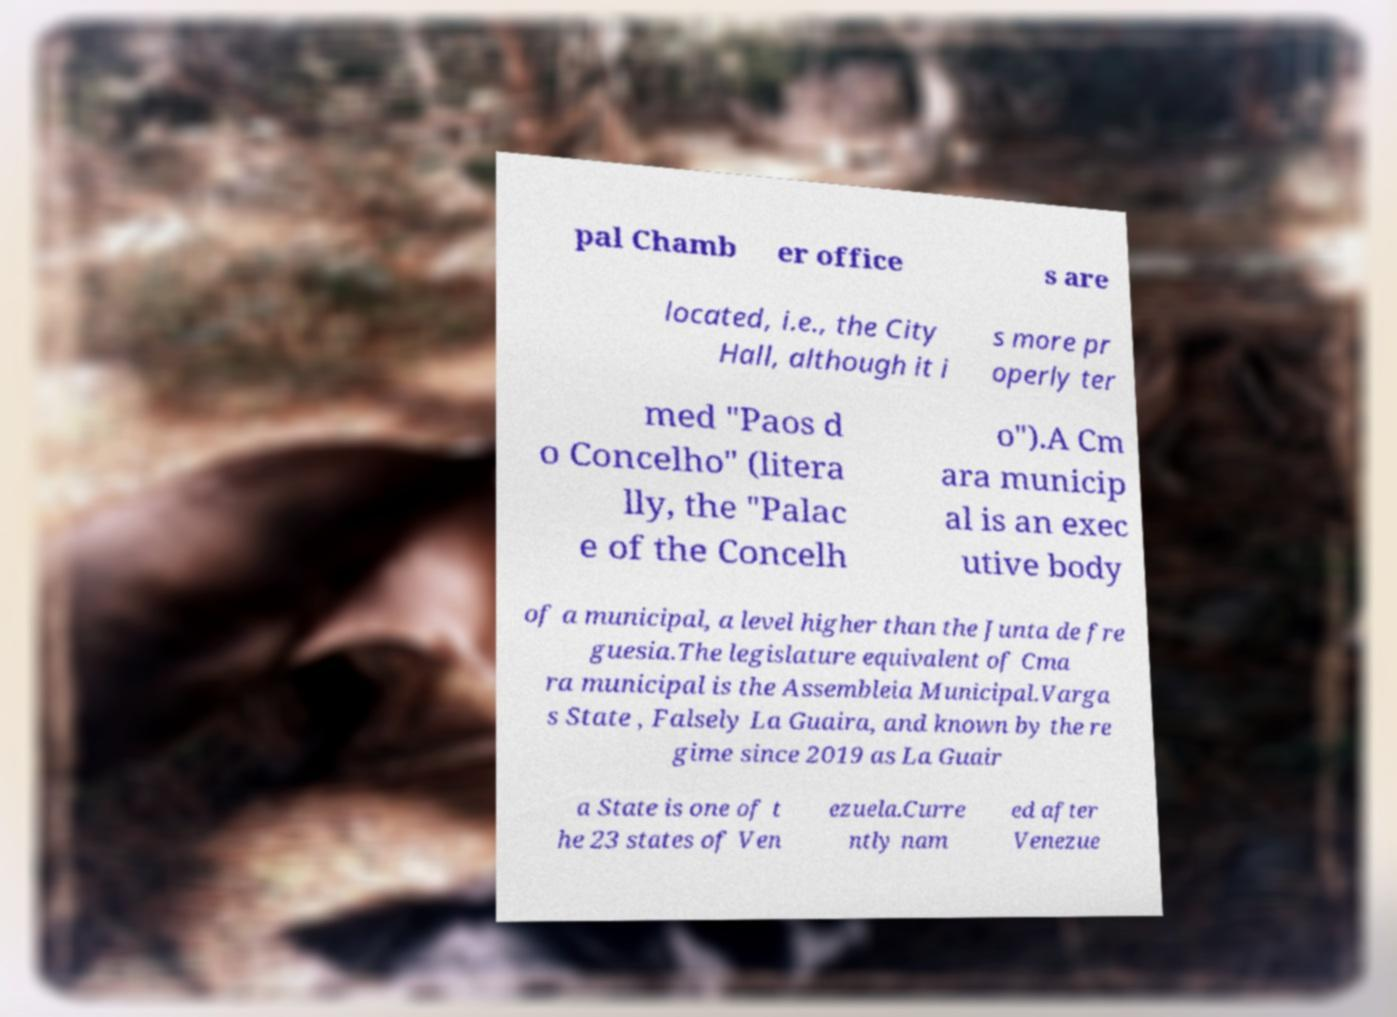Can you accurately transcribe the text from the provided image for me? pal Chamb er office s are located, i.e., the City Hall, although it i s more pr operly ter med "Paos d o Concelho" (litera lly, the "Palac e of the Concelh o").A Cm ara municip al is an exec utive body of a municipal, a level higher than the Junta de fre guesia.The legislature equivalent of Cma ra municipal is the Assembleia Municipal.Varga s State , Falsely La Guaira, and known by the re gime since 2019 as La Guair a State is one of t he 23 states of Ven ezuela.Curre ntly nam ed after Venezue 